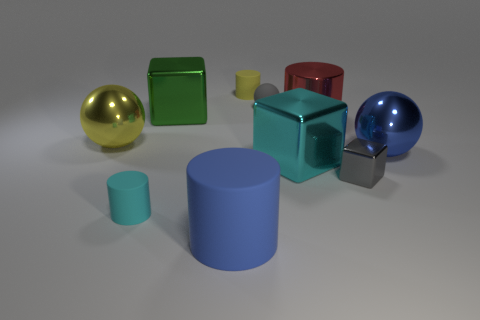Describe the lighting and shadows in the scene. The lighting in the image comes from the upper left, producing soft shadows to the lower right of each object, suggesting a diffused light source. 